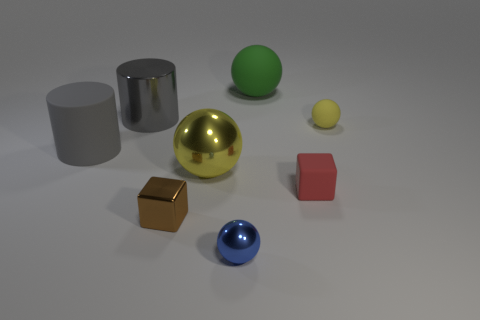What number of other things are the same color as the large rubber cylinder?
Ensure brevity in your answer.  1. Is the number of large matte cylinders that are behind the tiny yellow ball less than the number of tiny red metallic things?
Your answer should be compact. No. What color is the tiny metallic thing that is the same shape as the tiny yellow rubber object?
Your response must be concise. Blue. Is the size of the rubber object that is on the left side of the yellow metal object the same as the green thing?
Your answer should be very brief. Yes. There is a brown object that is left of the yellow matte object right of the red matte object; what is its size?
Your answer should be very brief. Small. Does the small yellow object have the same material as the tiny cube on the right side of the green ball?
Give a very brief answer. Yes. Is the number of large cylinders behind the green sphere less than the number of yellow spheres that are on the left side of the blue thing?
Give a very brief answer. Yes. The small thing that is the same material as the small red block is what color?
Offer a terse response. Yellow. There is a big metallic object that is on the right side of the shiny cube; is there a object in front of it?
Keep it short and to the point. Yes. What color is the other ball that is the same size as the green rubber ball?
Your response must be concise. Yellow. 